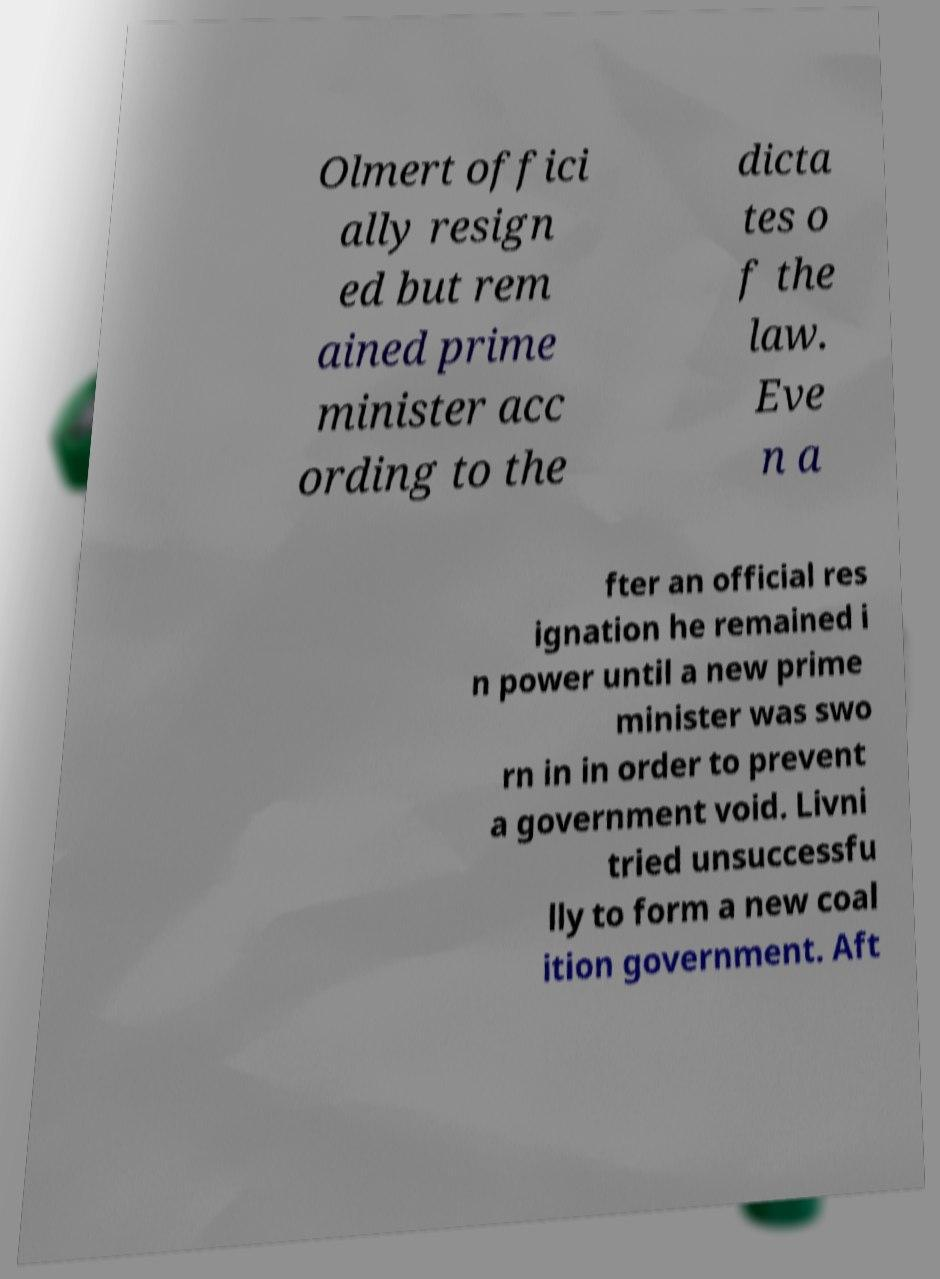There's text embedded in this image that I need extracted. Can you transcribe it verbatim? Olmert offici ally resign ed but rem ained prime minister acc ording to the dicta tes o f the law. Eve n a fter an official res ignation he remained i n power until a new prime minister was swo rn in in order to prevent a government void. Livni tried unsuccessfu lly to form a new coal ition government. Aft 